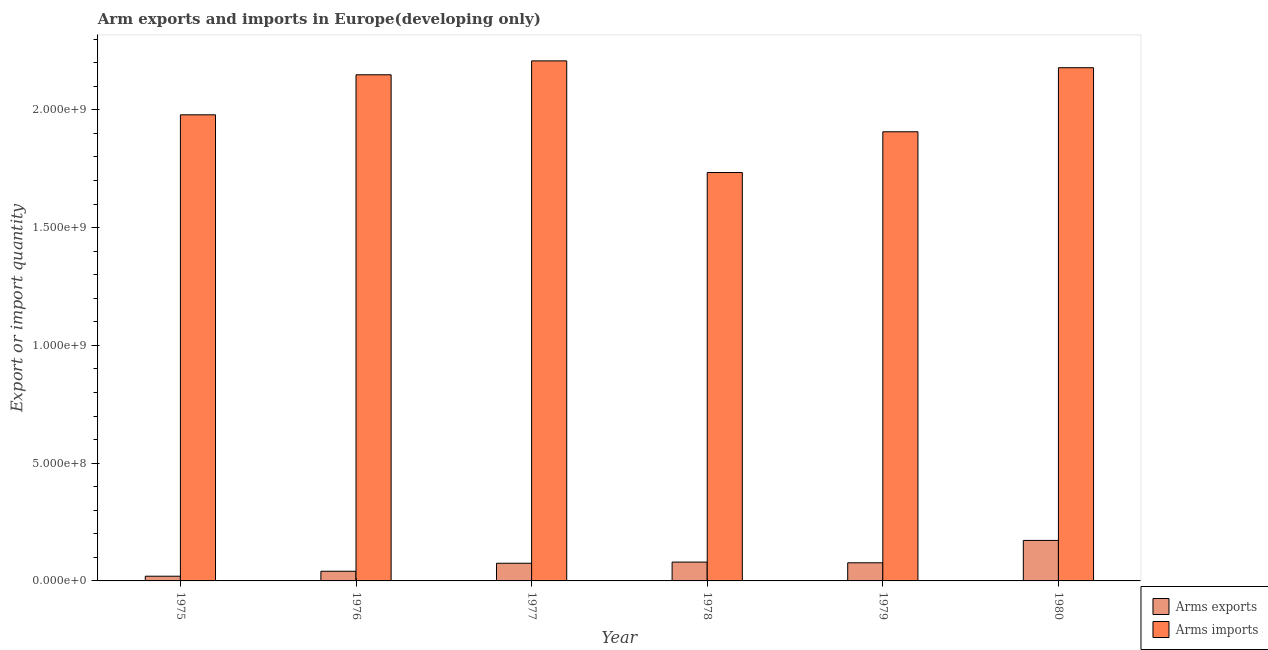How many different coloured bars are there?
Keep it short and to the point. 2. How many groups of bars are there?
Make the answer very short. 6. How many bars are there on the 1st tick from the right?
Your response must be concise. 2. What is the label of the 5th group of bars from the left?
Keep it short and to the point. 1979. In how many cases, is the number of bars for a given year not equal to the number of legend labels?
Ensure brevity in your answer.  0. What is the arms exports in 1976?
Offer a terse response. 4.10e+07. Across all years, what is the maximum arms exports?
Ensure brevity in your answer.  1.72e+08. Across all years, what is the minimum arms exports?
Your answer should be compact. 2.00e+07. In which year was the arms imports maximum?
Ensure brevity in your answer.  1977. In which year was the arms imports minimum?
Your response must be concise. 1978. What is the total arms exports in the graph?
Keep it short and to the point. 4.65e+08. What is the difference between the arms exports in 1977 and that in 1978?
Provide a succinct answer. -5.00e+06. What is the difference between the arms imports in 1979 and the arms exports in 1978?
Ensure brevity in your answer.  1.73e+08. What is the average arms exports per year?
Make the answer very short. 7.75e+07. In the year 1975, what is the difference between the arms exports and arms imports?
Provide a short and direct response. 0. What is the ratio of the arms exports in 1976 to that in 1980?
Provide a short and direct response. 0.24. Is the arms exports in 1978 less than that in 1980?
Offer a very short reply. Yes. Is the difference between the arms imports in 1978 and 1980 greater than the difference between the arms exports in 1978 and 1980?
Keep it short and to the point. No. What is the difference between the highest and the second highest arms imports?
Provide a succinct answer. 2.90e+07. What is the difference between the highest and the lowest arms imports?
Your answer should be very brief. 4.74e+08. In how many years, is the arms exports greater than the average arms exports taken over all years?
Offer a very short reply. 2. Is the sum of the arms imports in 1979 and 1980 greater than the maximum arms exports across all years?
Keep it short and to the point. Yes. What does the 2nd bar from the left in 1978 represents?
Your response must be concise. Arms imports. What does the 1st bar from the right in 1976 represents?
Offer a very short reply. Arms imports. How many bars are there?
Make the answer very short. 12. How many years are there in the graph?
Provide a short and direct response. 6. Does the graph contain any zero values?
Ensure brevity in your answer.  No. Does the graph contain grids?
Offer a terse response. No. Where does the legend appear in the graph?
Make the answer very short. Bottom right. How many legend labels are there?
Offer a very short reply. 2. What is the title of the graph?
Ensure brevity in your answer.  Arm exports and imports in Europe(developing only). What is the label or title of the X-axis?
Offer a very short reply. Year. What is the label or title of the Y-axis?
Your answer should be very brief. Export or import quantity. What is the Export or import quantity of Arms exports in 1975?
Ensure brevity in your answer.  2.00e+07. What is the Export or import quantity of Arms imports in 1975?
Your answer should be compact. 1.98e+09. What is the Export or import quantity in Arms exports in 1976?
Keep it short and to the point. 4.10e+07. What is the Export or import quantity of Arms imports in 1976?
Keep it short and to the point. 2.15e+09. What is the Export or import quantity in Arms exports in 1977?
Your response must be concise. 7.50e+07. What is the Export or import quantity of Arms imports in 1977?
Offer a very short reply. 2.21e+09. What is the Export or import quantity in Arms exports in 1978?
Offer a very short reply. 8.00e+07. What is the Export or import quantity in Arms imports in 1978?
Offer a terse response. 1.73e+09. What is the Export or import quantity in Arms exports in 1979?
Offer a terse response. 7.70e+07. What is the Export or import quantity in Arms imports in 1979?
Provide a short and direct response. 1.91e+09. What is the Export or import quantity of Arms exports in 1980?
Give a very brief answer. 1.72e+08. What is the Export or import quantity in Arms imports in 1980?
Provide a succinct answer. 2.18e+09. Across all years, what is the maximum Export or import quantity in Arms exports?
Your answer should be very brief. 1.72e+08. Across all years, what is the maximum Export or import quantity in Arms imports?
Give a very brief answer. 2.21e+09. Across all years, what is the minimum Export or import quantity of Arms imports?
Your response must be concise. 1.73e+09. What is the total Export or import quantity of Arms exports in the graph?
Provide a succinct answer. 4.65e+08. What is the total Export or import quantity in Arms imports in the graph?
Your answer should be very brief. 1.22e+1. What is the difference between the Export or import quantity of Arms exports in 1975 and that in 1976?
Provide a succinct answer. -2.10e+07. What is the difference between the Export or import quantity in Arms imports in 1975 and that in 1976?
Offer a terse response. -1.70e+08. What is the difference between the Export or import quantity in Arms exports in 1975 and that in 1977?
Give a very brief answer. -5.50e+07. What is the difference between the Export or import quantity of Arms imports in 1975 and that in 1977?
Keep it short and to the point. -2.29e+08. What is the difference between the Export or import quantity in Arms exports in 1975 and that in 1978?
Provide a succinct answer. -6.00e+07. What is the difference between the Export or import quantity in Arms imports in 1975 and that in 1978?
Offer a terse response. 2.45e+08. What is the difference between the Export or import quantity in Arms exports in 1975 and that in 1979?
Give a very brief answer. -5.70e+07. What is the difference between the Export or import quantity in Arms imports in 1975 and that in 1979?
Your answer should be very brief. 7.20e+07. What is the difference between the Export or import quantity of Arms exports in 1975 and that in 1980?
Provide a short and direct response. -1.52e+08. What is the difference between the Export or import quantity of Arms imports in 1975 and that in 1980?
Your answer should be compact. -2.00e+08. What is the difference between the Export or import quantity of Arms exports in 1976 and that in 1977?
Provide a short and direct response. -3.40e+07. What is the difference between the Export or import quantity in Arms imports in 1976 and that in 1977?
Offer a very short reply. -5.90e+07. What is the difference between the Export or import quantity of Arms exports in 1976 and that in 1978?
Offer a very short reply. -3.90e+07. What is the difference between the Export or import quantity in Arms imports in 1976 and that in 1978?
Ensure brevity in your answer.  4.15e+08. What is the difference between the Export or import quantity in Arms exports in 1976 and that in 1979?
Your answer should be very brief. -3.60e+07. What is the difference between the Export or import quantity in Arms imports in 1976 and that in 1979?
Ensure brevity in your answer.  2.42e+08. What is the difference between the Export or import quantity in Arms exports in 1976 and that in 1980?
Provide a succinct answer. -1.31e+08. What is the difference between the Export or import quantity in Arms imports in 1976 and that in 1980?
Provide a short and direct response. -3.00e+07. What is the difference between the Export or import quantity in Arms exports in 1977 and that in 1978?
Ensure brevity in your answer.  -5.00e+06. What is the difference between the Export or import quantity of Arms imports in 1977 and that in 1978?
Your answer should be very brief. 4.74e+08. What is the difference between the Export or import quantity in Arms imports in 1977 and that in 1979?
Keep it short and to the point. 3.01e+08. What is the difference between the Export or import quantity of Arms exports in 1977 and that in 1980?
Your answer should be very brief. -9.70e+07. What is the difference between the Export or import quantity in Arms imports in 1977 and that in 1980?
Keep it short and to the point. 2.90e+07. What is the difference between the Export or import quantity of Arms imports in 1978 and that in 1979?
Your response must be concise. -1.73e+08. What is the difference between the Export or import quantity in Arms exports in 1978 and that in 1980?
Offer a terse response. -9.20e+07. What is the difference between the Export or import quantity of Arms imports in 1978 and that in 1980?
Your response must be concise. -4.45e+08. What is the difference between the Export or import quantity in Arms exports in 1979 and that in 1980?
Your response must be concise. -9.50e+07. What is the difference between the Export or import quantity of Arms imports in 1979 and that in 1980?
Ensure brevity in your answer.  -2.72e+08. What is the difference between the Export or import quantity of Arms exports in 1975 and the Export or import quantity of Arms imports in 1976?
Provide a succinct answer. -2.13e+09. What is the difference between the Export or import quantity in Arms exports in 1975 and the Export or import quantity in Arms imports in 1977?
Offer a very short reply. -2.19e+09. What is the difference between the Export or import quantity in Arms exports in 1975 and the Export or import quantity in Arms imports in 1978?
Offer a terse response. -1.71e+09. What is the difference between the Export or import quantity of Arms exports in 1975 and the Export or import quantity of Arms imports in 1979?
Make the answer very short. -1.89e+09. What is the difference between the Export or import quantity of Arms exports in 1975 and the Export or import quantity of Arms imports in 1980?
Your answer should be compact. -2.16e+09. What is the difference between the Export or import quantity of Arms exports in 1976 and the Export or import quantity of Arms imports in 1977?
Provide a short and direct response. -2.17e+09. What is the difference between the Export or import quantity in Arms exports in 1976 and the Export or import quantity in Arms imports in 1978?
Provide a short and direct response. -1.69e+09. What is the difference between the Export or import quantity of Arms exports in 1976 and the Export or import quantity of Arms imports in 1979?
Your answer should be very brief. -1.87e+09. What is the difference between the Export or import quantity of Arms exports in 1976 and the Export or import quantity of Arms imports in 1980?
Offer a terse response. -2.14e+09. What is the difference between the Export or import quantity in Arms exports in 1977 and the Export or import quantity in Arms imports in 1978?
Ensure brevity in your answer.  -1.66e+09. What is the difference between the Export or import quantity in Arms exports in 1977 and the Export or import quantity in Arms imports in 1979?
Offer a terse response. -1.83e+09. What is the difference between the Export or import quantity in Arms exports in 1977 and the Export or import quantity in Arms imports in 1980?
Make the answer very short. -2.10e+09. What is the difference between the Export or import quantity in Arms exports in 1978 and the Export or import quantity in Arms imports in 1979?
Offer a very short reply. -1.83e+09. What is the difference between the Export or import quantity of Arms exports in 1978 and the Export or import quantity of Arms imports in 1980?
Your answer should be very brief. -2.10e+09. What is the difference between the Export or import quantity in Arms exports in 1979 and the Export or import quantity in Arms imports in 1980?
Offer a very short reply. -2.10e+09. What is the average Export or import quantity of Arms exports per year?
Your answer should be very brief. 7.75e+07. What is the average Export or import quantity in Arms imports per year?
Your response must be concise. 2.03e+09. In the year 1975, what is the difference between the Export or import quantity of Arms exports and Export or import quantity of Arms imports?
Provide a short and direct response. -1.96e+09. In the year 1976, what is the difference between the Export or import quantity in Arms exports and Export or import quantity in Arms imports?
Your response must be concise. -2.11e+09. In the year 1977, what is the difference between the Export or import quantity of Arms exports and Export or import quantity of Arms imports?
Provide a short and direct response. -2.13e+09. In the year 1978, what is the difference between the Export or import quantity in Arms exports and Export or import quantity in Arms imports?
Ensure brevity in your answer.  -1.65e+09. In the year 1979, what is the difference between the Export or import quantity in Arms exports and Export or import quantity in Arms imports?
Make the answer very short. -1.83e+09. In the year 1980, what is the difference between the Export or import quantity in Arms exports and Export or import quantity in Arms imports?
Provide a short and direct response. -2.01e+09. What is the ratio of the Export or import quantity of Arms exports in 1975 to that in 1976?
Ensure brevity in your answer.  0.49. What is the ratio of the Export or import quantity of Arms imports in 1975 to that in 1976?
Provide a succinct answer. 0.92. What is the ratio of the Export or import quantity of Arms exports in 1975 to that in 1977?
Your response must be concise. 0.27. What is the ratio of the Export or import quantity in Arms imports in 1975 to that in 1977?
Give a very brief answer. 0.9. What is the ratio of the Export or import quantity in Arms exports in 1975 to that in 1978?
Your answer should be very brief. 0.25. What is the ratio of the Export or import quantity of Arms imports in 1975 to that in 1978?
Make the answer very short. 1.14. What is the ratio of the Export or import quantity in Arms exports in 1975 to that in 1979?
Keep it short and to the point. 0.26. What is the ratio of the Export or import quantity of Arms imports in 1975 to that in 1979?
Offer a very short reply. 1.04. What is the ratio of the Export or import quantity of Arms exports in 1975 to that in 1980?
Offer a terse response. 0.12. What is the ratio of the Export or import quantity of Arms imports in 1975 to that in 1980?
Offer a very short reply. 0.91. What is the ratio of the Export or import quantity of Arms exports in 1976 to that in 1977?
Your response must be concise. 0.55. What is the ratio of the Export or import quantity of Arms imports in 1976 to that in 1977?
Give a very brief answer. 0.97. What is the ratio of the Export or import quantity of Arms exports in 1976 to that in 1978?
Provide a short and direct response. 0.51. What is the ratio of the Export or import quantity of Arms imports in 1976 to that in 1978?
Ensure brevity in your answer.  1.24. What is the ratio of the Export or import quantity of Arms exports in 1976 to that in 1979?
Offer a terse response. 0.53. What is the ratio of the Export or import quantity in Arms imports in 1976 to that in 1979?
Keep it short and to the point. 1.13. What is the ratio of the Export or import quantity of Arms exports in 1976 to that in 1980?
Make the answer very short. 0.24. What is the ratio of the Export or import quantity of Arms imports in 1976 to that in 1980?
Make the answer very short. 0.99. What is the ratio of the Export or import quantity of Arms imports in 1977 to that in 1978?
Your response must be concise. 1.27. What is the ratio of the Export or import quantity in Arms imports in 1977 to that in 1979?
Offer a very short reply. 1.16. What is the ratio of the Export or import quantity in Arms exports in 1977 to that in 1980?
Make the answer very short. 0.44. What is the ratio of the Export or import quantity of Arms imports in 1977 to that in 1980?
Your response must be concise. 1.01. What is the ratio of the Export or import quantity of Arms exports in 1978 to that in 1979?
Your response must be concise. 1.04. What is the ratio of the Export or import quantity of Arms imports in 1978 to that in 1979?
Offer a very short reply. 0.91. What is the ratio of the Export or import quantity of Arms exports in 1978 to that in 1980?
Make the answer very short. 0.47. What is the ratio of the Export or import quantity in Arms imports in 1978 to that in 1980?
Your answer should be compact. 0.8. What is the ratio of the Export or import quantity of Arms exports in 1979 to that in 1980?
Provide a succinct answer. 0.45. What is the ratio of the Export or import quantity of Arms imports in 1979 to that in 1980?
Provide a short and direct response. 0.88. What is the difference between the highest and the second highest Export or import quantity in Arms exports?
Offer a very short reply. 9.20e+07. What is the difference between the highest and the second highest Export or import quantity in Arms imports?
Provide a short and direct response. 2.90e+07. What is the difference between the highest and the lowest Export or import quantity in Arms exports?
Offer a very short reply. 1.52e+08. What is the difference between the highest and the lowest Export or import quantity of Arms imports?
Provide a succinct answer. 4.74e+08. 